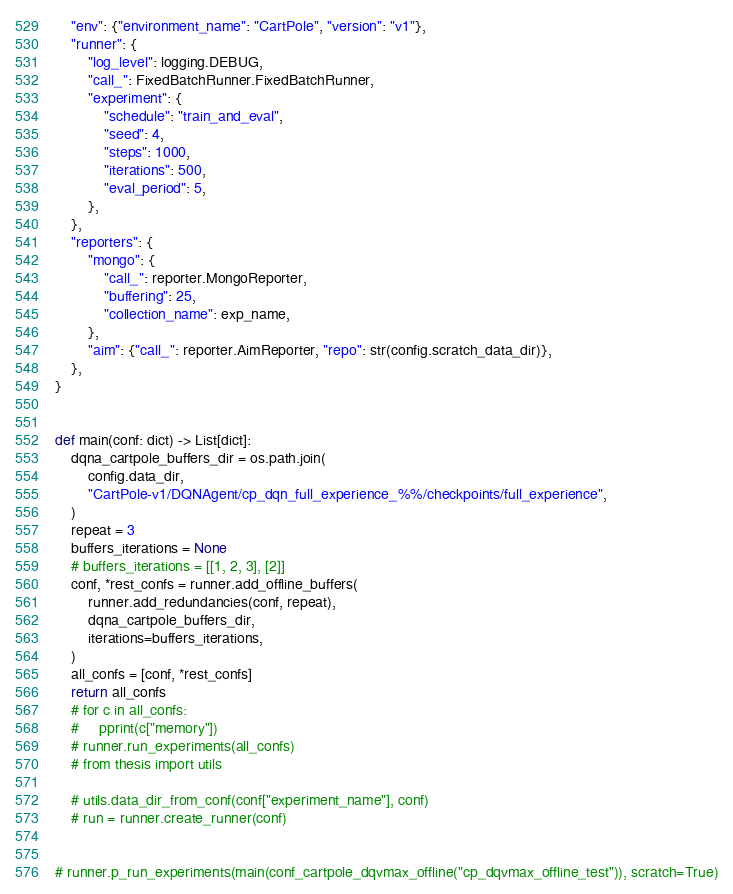Convert code to text. <code><loc_0><loc_0><loc_500><loc_500><_Python_>    "env": {"environment_name": "CartPole", "version": "v1"},
    "runner": {
        "log_level": logging.DEBUG,
        "call_": FixedBatchRunner.FixedBatchRunner,
        "experiment": {
            "schedule": "train_and_eval",
            "seed": 4,
            "steps": 1000,
            "iterations": 500,
            "eval_period": 5,
        },
    },
    "reporters": {
        "mongo": {
            "call_": reporter.MongoReporter,
            "buffering": 25,
            "collection_name": exp_name,
        },
        "aim": {"call_": reporter.AimReporter, "repo": str(config.scratch_data_dir)},
    },
}


def main(conf: dict) -> List[dict]:
    dqna_cartpole_buffers_dir = os.path.join(
        config.data_dir,
        "CartPole-v1/DQNAgent/cp_dqn_full_experience_%%/checkpoints/full_experience",
    )
    repeat = 3
    buffers_iterations = None
    # buffers_iterations = [[1, 2, 3], [2]]
    conf, *rest_confs = runner.add_offline_buffers(
        runner.add_redundancies(conf, repeat),
        dqna_cartpole_buffers_dir,
        iterations=buffers_iterations,
    )
    all_confs = [conf, *rest_confs]
    return all_confs
    # for c in all_confs:
    #     pprint(c["memory"])
    # runner.run_experiments(all_confs)
    # from thesis import utils

    # utils.data_dir_from_conf(conf["experiment_name"], conf)
    # run = runner.create_runner(conf)


# runner.p_run_experiments(main(conf_cartpole_dqvmax_offline("cp_dqvmax_offline_test")), scratch=True)
</code> 